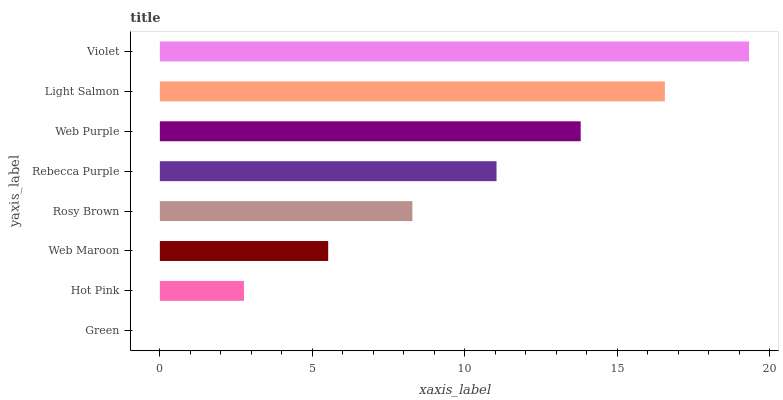Is Green the minimum?
Answer yes or no. Yes. Is Violet the maximum?
Answer yes or no. Yes. Is Hot Pink the minimum?
Answer yes or no. No. Is Hot Pink the maximum?
Answer yes or no. No. Is Hot Pink greater than Green?
Answer yes or no. Yes. Is Green less than Hot Pink?
Answer yes or no. Yes. Is Green greater than Hot Pink?
Answer yes or no. No. Is Hot Pink less than Green?
Answer yes or no. No. Is Rebecca Purple the high median?
Answer yes or no. Yes. Is Rosy Brown the low median?
Answer yes or no. Yes. Is Web Purple the high median?
Answer yes or no. No. Is Light Salmon the low median?
Answer yes or no. No. 